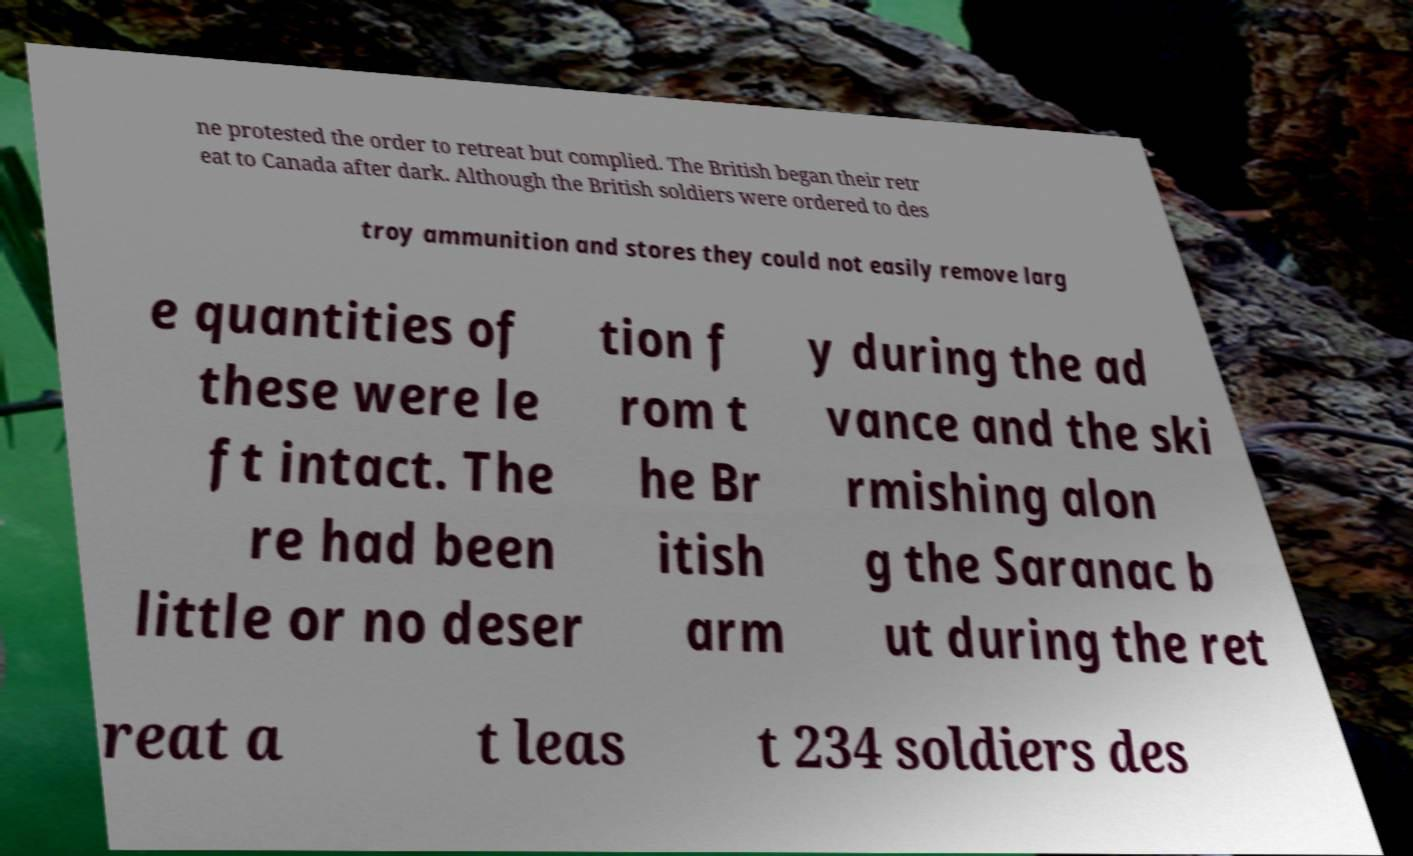Please read and relay the text visible in this image. What does it say? ne protested the order to retreat but complied. The British began their retr eat to Canada after dark. Although the British soldiers were ordered to des troy ammunition and stores they could not easily remove larg e quantities of these were le ft intact. The re had been little or no deser tion f rom t he Br itish arm y during the ad vance and the ski rmishing alon g the Saranac b ut during the ret reat a t leas t 234 soldiers des 